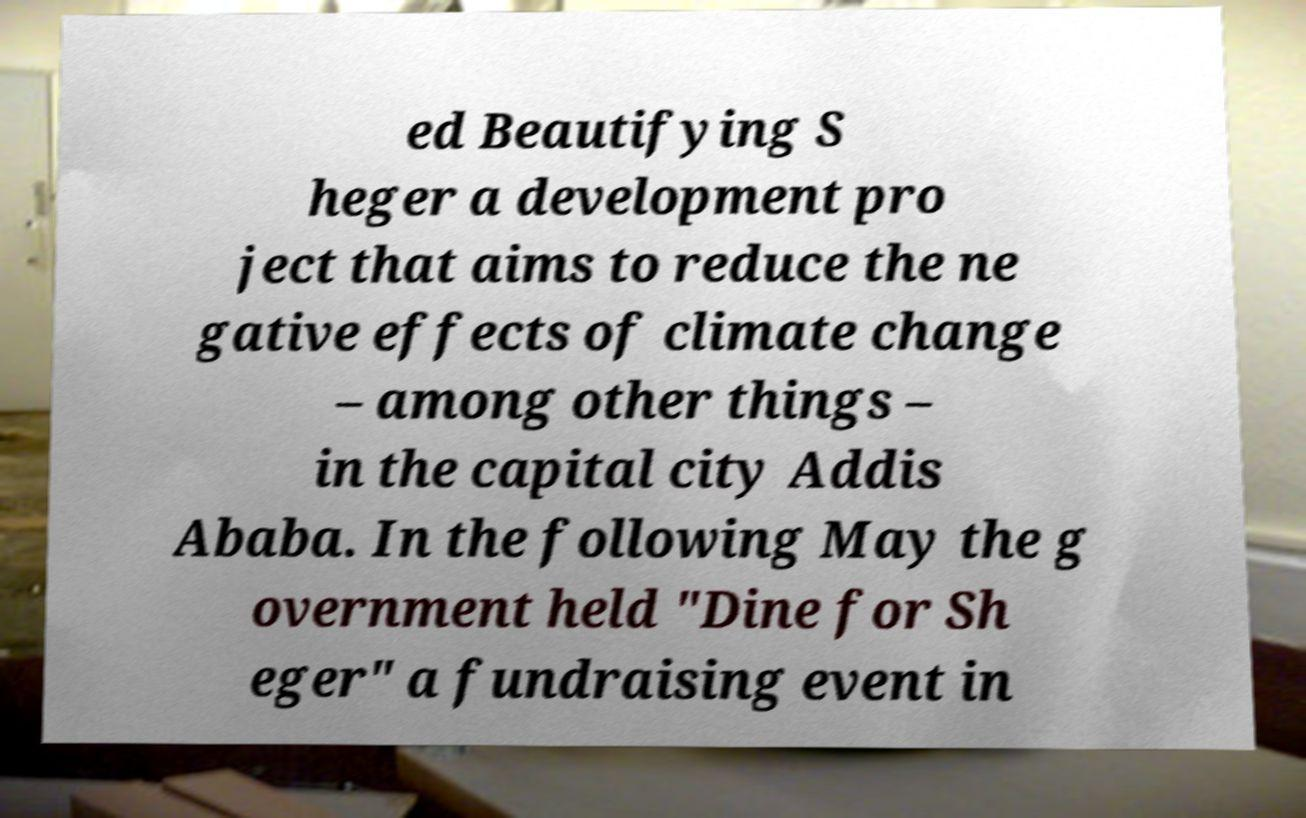Please read and relay the text visible in this image. What does it say? ed Beautifying S heger a development pro ject that aims to reduce the ne gative effects of climate change – among other things – in the capital city Addis Ababa. In the following May the g overnment held "Dine for Sh eger" a fundraising event in 